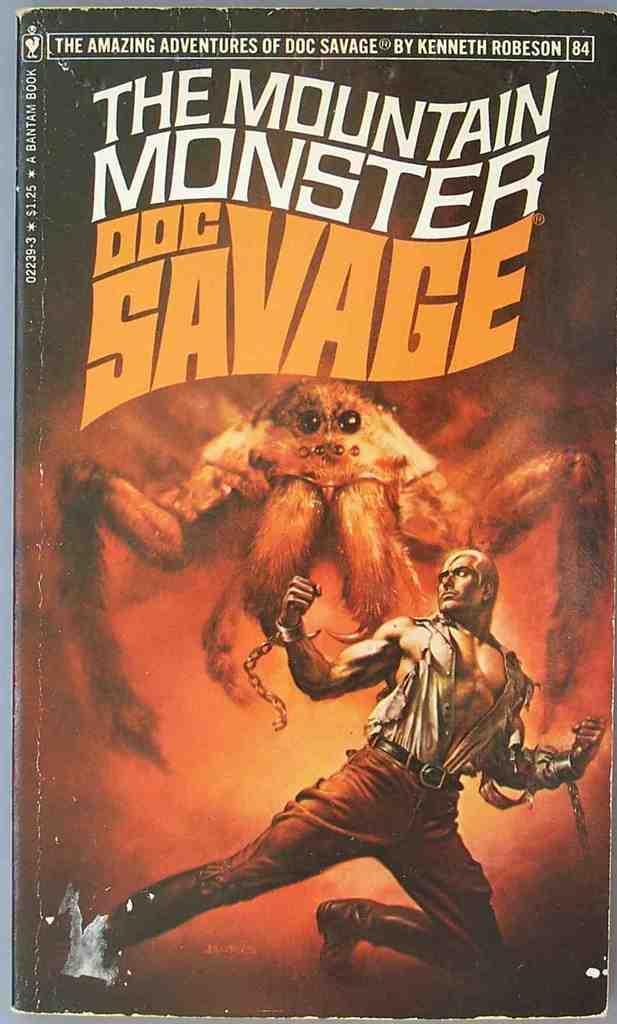How would you summarize this image in a sentence or two? This image is a poster of DOC SAVAGE and I can see a monster like spider in the center of the image and I can see a person with a broken handcuffs in the bottom right corner of the image 